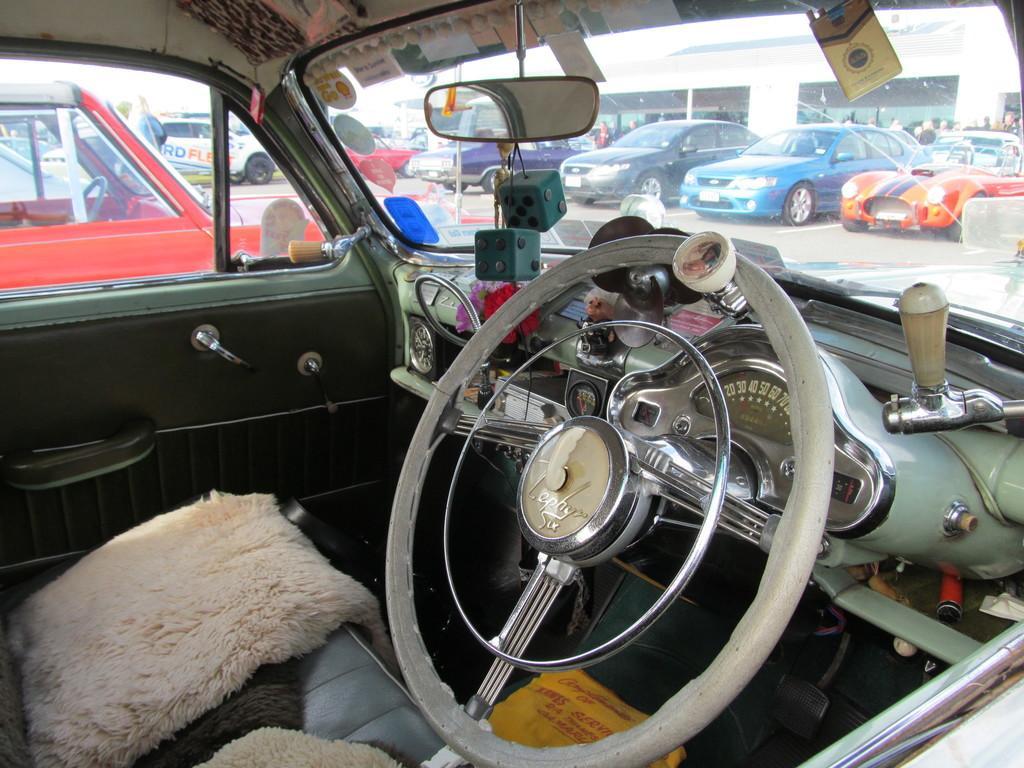How would you summarize this image in a sentence or two? In this image we can see inside of a vehicle. Through the vehicle we can see other vehicles and building. Inside the vehicle there is steering. An object is hung on the mirror. Also there are flowers and some other things. 